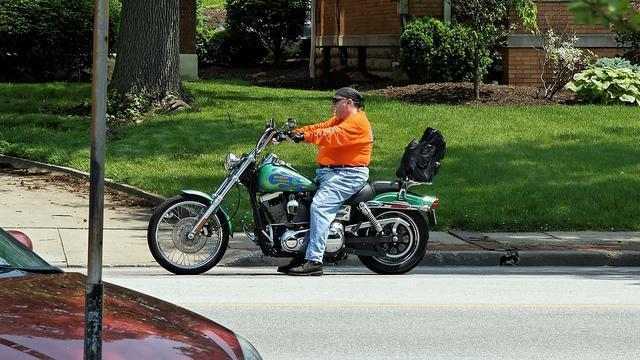How many people on the motorcycle?
Give a very brief answer. 1. How many motorcycles are pictured?
Give a very brief answer. 1. How many horses are in the photo?
Give a very brief answer. 0. 